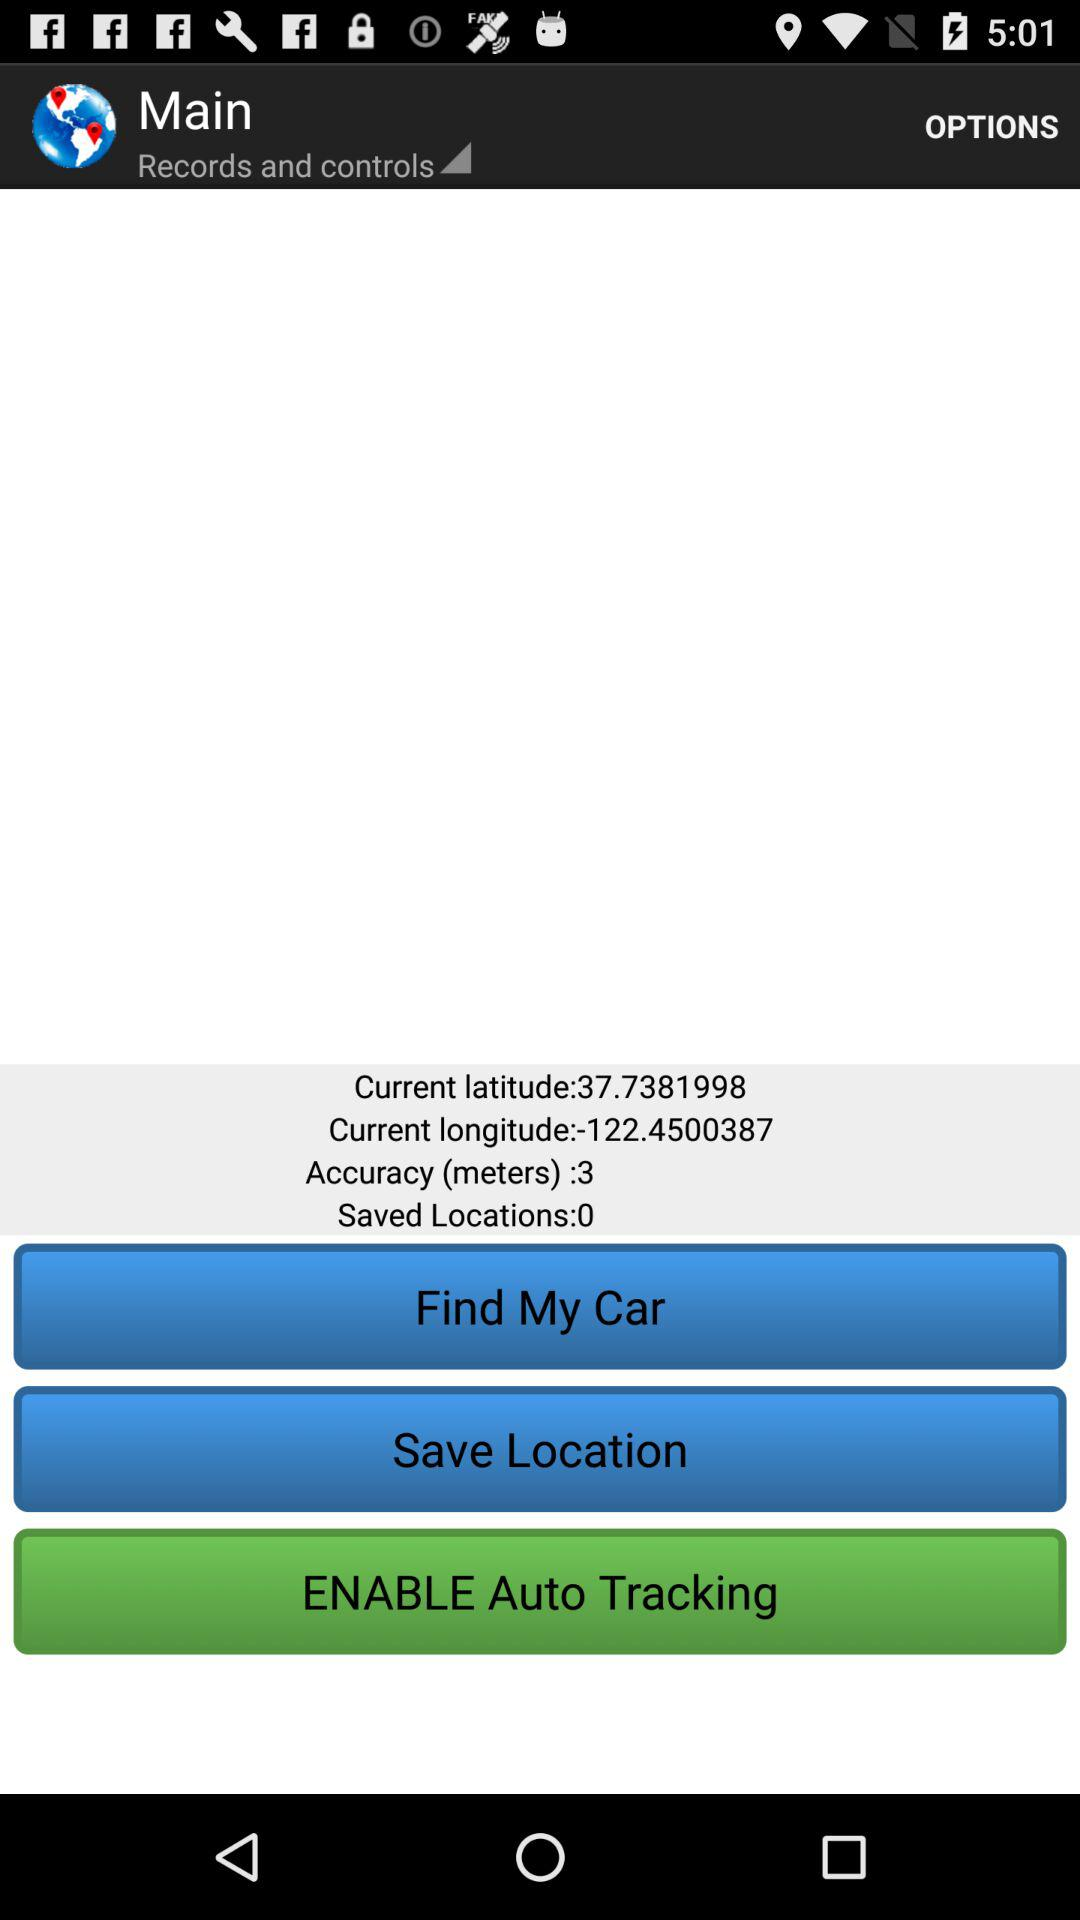What is the accuracy? The accuracy is 3. 